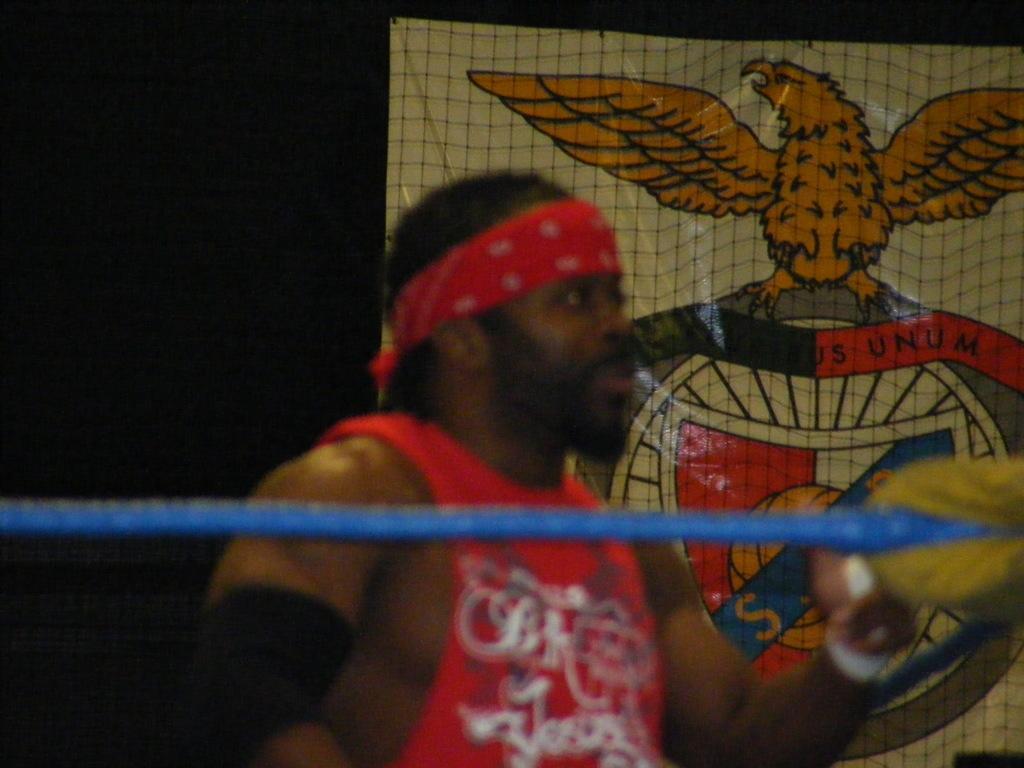Can you describe this image briefly? In this picture there is a man in the center of the image and there is a rope in front of him, there is a poster in the background area of the image. 